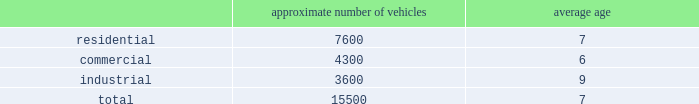Fleet automation approximately 66% ( 66 % ) of our residential routes have been converted to automated single driver trucks .
By converting our residential routes to automated service , we reduce labor costs , improve driver productivity and create a safer work environment for our employees .
Additionally , communities using automated vehicles have higher participation rates in recycling programs , thereby complementing our initiative to expand our recycling capabilities .
Fleet conversion to compressed natural gas ( cng ) approximately 12% ( 12 % ) of our fleet operates on natural gas .
We expect to continue our gradual fleet conversion to cng , our preferred alternative fuel technology , as part of our ordinary annual fleet replacement process .
We believe a gradual fleet conversion is most prudent to realize the full value of our previous fleet investments .
Approximately 50% ( 50 % ) of our replacement vehicle purchases during 2013 were cng vehicles .
We believe using cng vehicles provides us a competitive advantage in communities with strict clean emission objectives or initiatives that focus on protecting the environment .
Although upfront costs are higher , we expect that using natural gas will reduce our overall fleet operating costs through lower fuel expenses .
Standardized maintenance based on an industry trade publication , we operate the eighth largest vocational fleet in the united states .
As of december 31 , 2013 , our average fleet age in years , by line of business , was as follows : approximate number of vehicles average age .
Through standardization of core functions , we believe we can minimize variability in our maintenance processes resulting in higher vehicle quality while extending the service life of our fleet .
We believe operating a more reliable , safer and efficient fleet will lower our operating costs .
We have completed implementation of standardized maintenance programs for approximately 45% ( 45 % ) of our fleet maintenance operations as of december 31 , 2013 .
Cash utilization strategy key components of our cash utilization strategy include increasing free cash flow and improving our return on invested capital .
Our definition of free cash flow , which is not a measure determined in accordance with united states generally accepted accounting principles ( u.s .
Gaap ) , is cash provided by operating activities less purchases of property and equipment , plus proceeds from sales of property and equipment as presented in our consolidated statements of cash flows .
For a discussion and reconciliation of free cash flow , you should read the 201cfree cash flow 201d section of our management 2019s discussion and analysis of financial condition and results of operations contained in item 7 of this form 10-k .
We believe free cash flow drives shareholder value and provides useful information regarding the recurring cash provided by our operations .
Free cash flow also demonstrates our ability to execute our cash utilization strategy , which includes investments in acquisitions and returning a majority of free cash flow to our shareholders through dividends and share repurchases .
We are committed to an efficient capital structure and maintaining our investment grade rating .
We manage our free cash flow by ensuring that capital expenditures and operating asset levels are appropriate in light of our existing business and growth opportunities , as well as by closely managing our working capital , which consists primarily of accounts receivable , accounts payable , and accrued landfill and environmental costs. .
As of december 31 , 2013 what was the ratio of the number of vehicles for the residential to the industrial? 
Rationale: the are 2.11 residential vehicles for every industrial vehicle
Computations: (7600 / 3600)
Answer: 2.11111. 